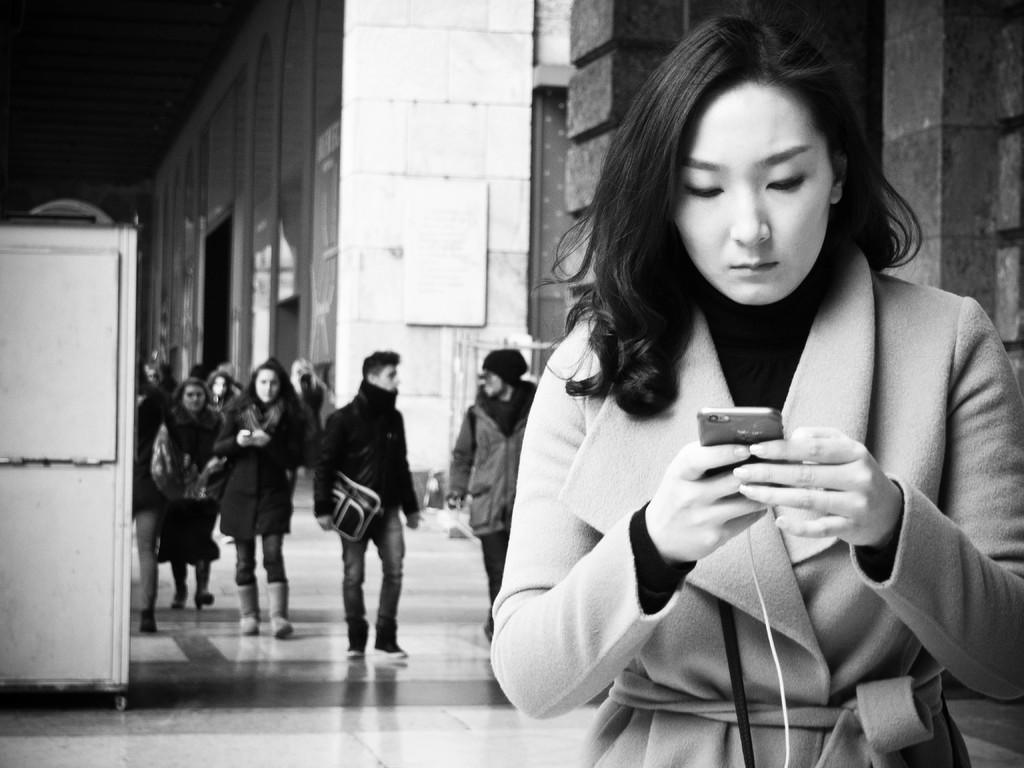In one or two sentences, can you explain what this image depicts? This is a black and white picture, in this image we can see a few people, among them some are carrying the objects, there are some buildings, on the wall we can see a few boards, on the left side of the image it looks like a cupboard. 